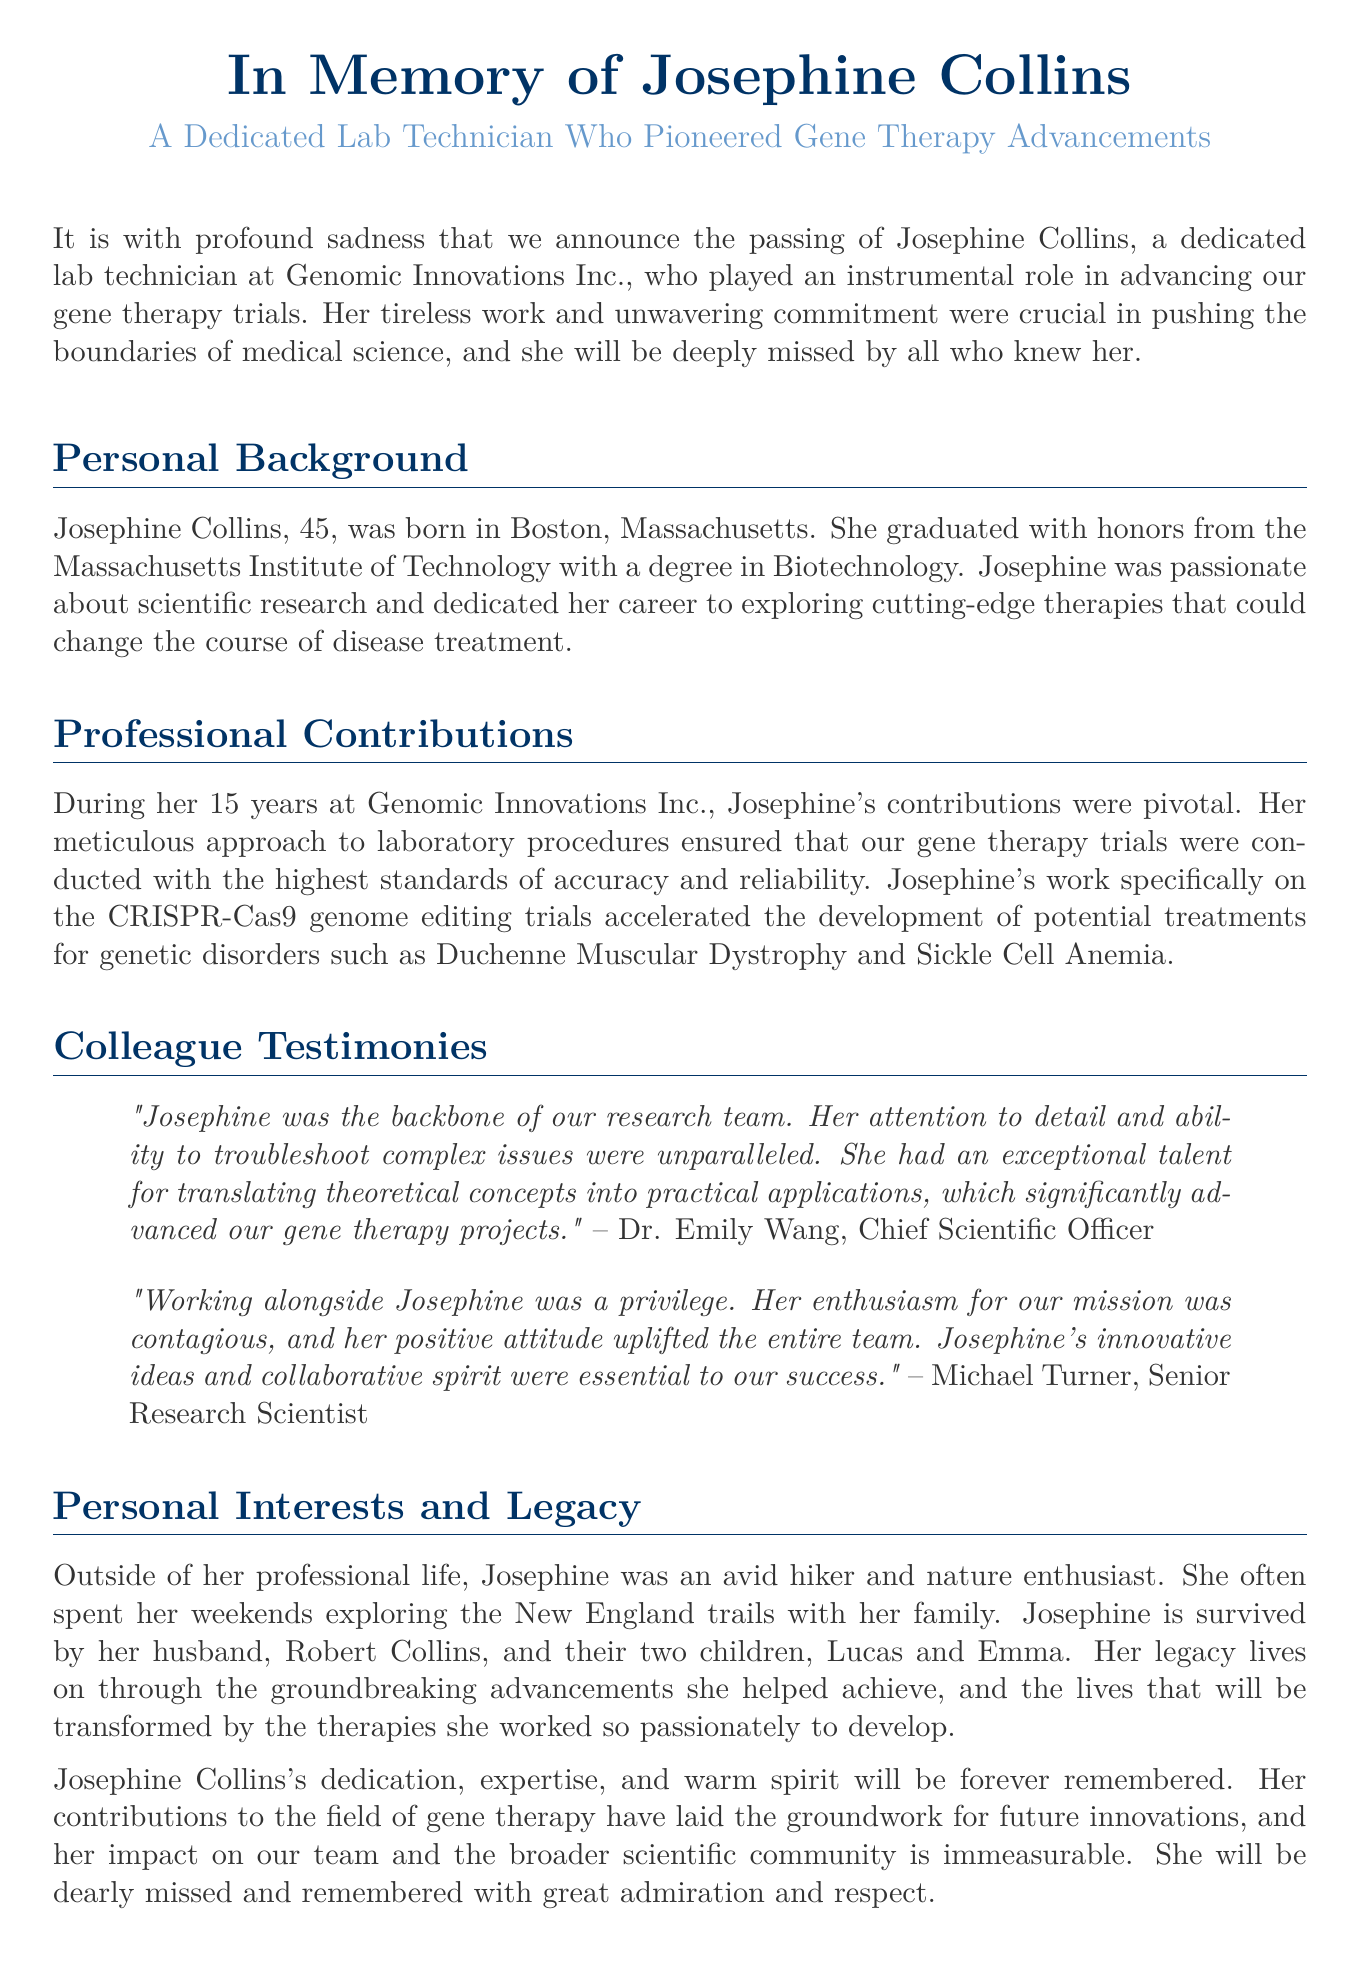What was Josephine Collins's age at the time of her passing? The document states her age as 45 years old.
Answer: 45 Where did Josephine graduate from? The document mentions she graduated from the Massachusetts Institute of Technology.
Answer: Massachusetts Institute of Technology How many years did Josephine work at Genomic Innovations Inc.? The document indicates she worked there for 15 years.
Answer: 15 years What specific genome editing trials did Josephine work on? The document states that she worked on the CRISPR-Cas9 genome editing trials.
Answer: CRISPR-Cas9 Which two genetic disorders were mentioned in relation to Josephine's work? The document lists Duchenne Muscular Dystrophy and Sickle Cell Anemia as related to her work.
Answer: Duchenne Muscular Dystrophy and Sickle Cell Anemia Who referred to Josephine as "the backbone of our research team"? The document attributes this statement to Dr. Emily Wang, the Chief Scientific Officer.
Answer: Dr. Emily Wang What outdoor activity did Josephine enjoy? The document mentions she was an avid hiker.
Answer: Hiking What is one of Josephine’s personal interests? The document notes her interest in nature.
Answer: Nature Who survives Josephine? The document states she is survived by her husband, Robert Collins, and their two children, Lucas and Emma.
Answer: Robert Collins, Lucas, and Emma 